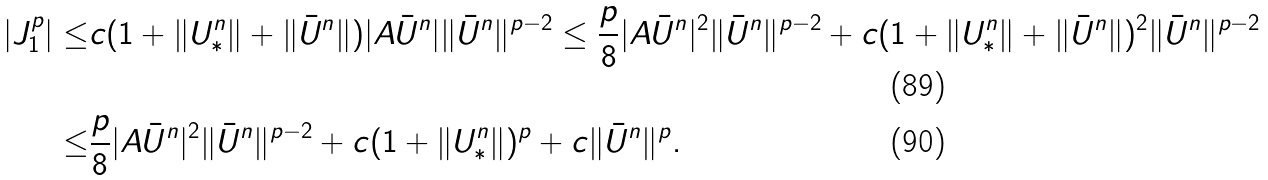Convert formula to latex. <formula><loc_0><loc_0><loc_500><loc_500>| J _ { 1 } ^ { p } | \leq & c ( 1 + \| U ^ { n } _ { * } \| + \| \bar { U } ^ { n } \| ) | A \bar { U } ^ { n } | \| \bar { U } ^ { n } \| ^ { p - 2 } \leq \frac { p } { 8 } | A \bar { U } ^ { n } | ^ { 2 } \| \bar { U } ^ { n } \| ^ { p - 2 } + c ( 1 + \| U ^ { n } _ { * } \| + \| \bar { U } ^ { n } \| ) ^ { 2 } \| \bar { U } ^ { n } \| ^ { p - 2 } \\ \leq & \frac { p } { 8 } | A \bar { U } ^ { n } | ^ { 2 } \| \bar { U } ^ { n } \| ^ { p - 2 } + c ( 1 + \| U ^ { n } _ { * } \| ) ^ { p } + c \| \bar { U } ^ { n } \| ^ { p } .</formula> 